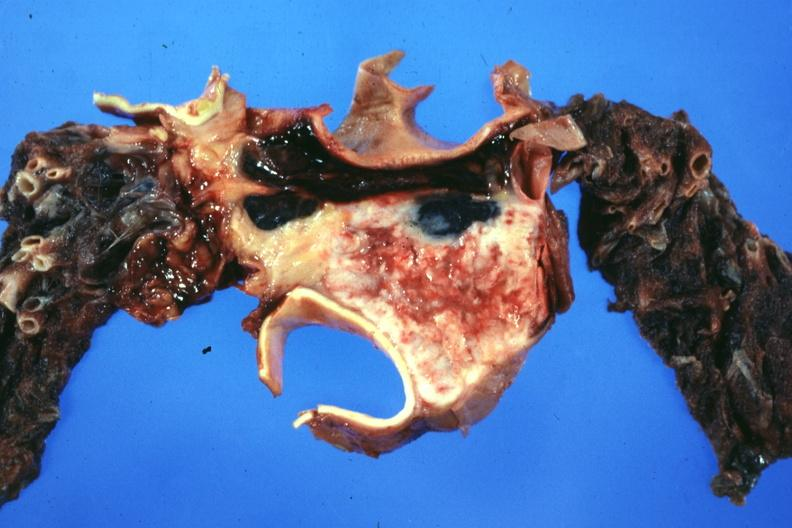what is present?
Answer the question using a single word or phrase. Thymus 